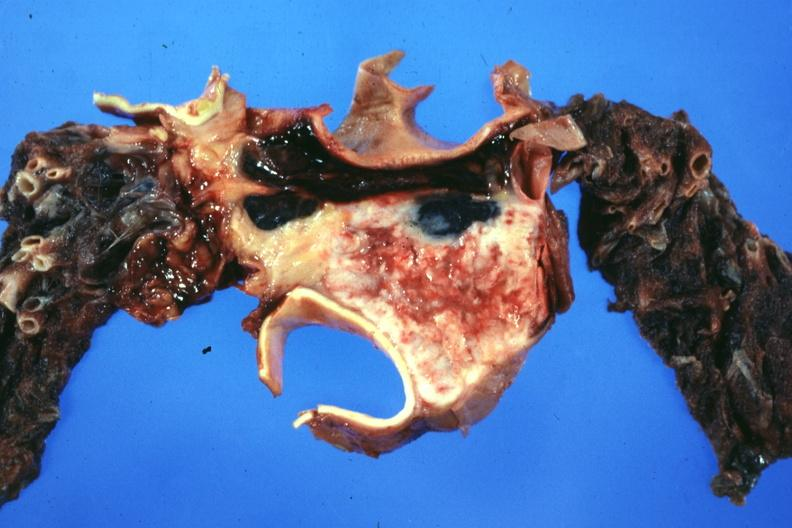what is present?
Answer the question using a single word or phrase. Thymus 